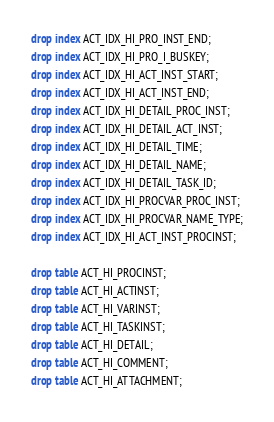Convert code to text. <code><loc_0><loc_0><loc_500><loc_500><_SQL_>drop index ACT_IDX_HI_PRO_INST_END;
drop index ACT_IDX_HI_PRO_I_BUSKEY;
drop index ACT_IDX_HI_ACT_INST_START;
drop index ACT_IDX_HI_ACT_INST_END;
drop index ACT_IDX_HI_DETAIL_PROC_INST;
drop index ACT_IDX_HI_DETAIL_ACT_INST;
drop index ACT_IDX_HI_DETAIL_TIME;
drop index ACT_IDX_HI_DETAIL_NAME;
drop index ACT_IDX_HI_DETAIL_TASK_ID;
drop index ACT_IDX_HI_PROCVAR_PROC_INST;
drop index ACT_IDX_HI_PROCVAR_NAME_TYPE;
drop index ACT_IDX_HI_ACT_INST_PROCINST;

drop table ACT_HI_PROCINST;
drop table ACT_HI_ACTINST;
drop table ACT_HI_VARINST;
drop table ACT_HI_TASKINST;
drop table ACT_HI_DETAIL;
drop table ACT_HI_COMMENT;
drop table ACT_HI_ATTACHMENT;

</code> 